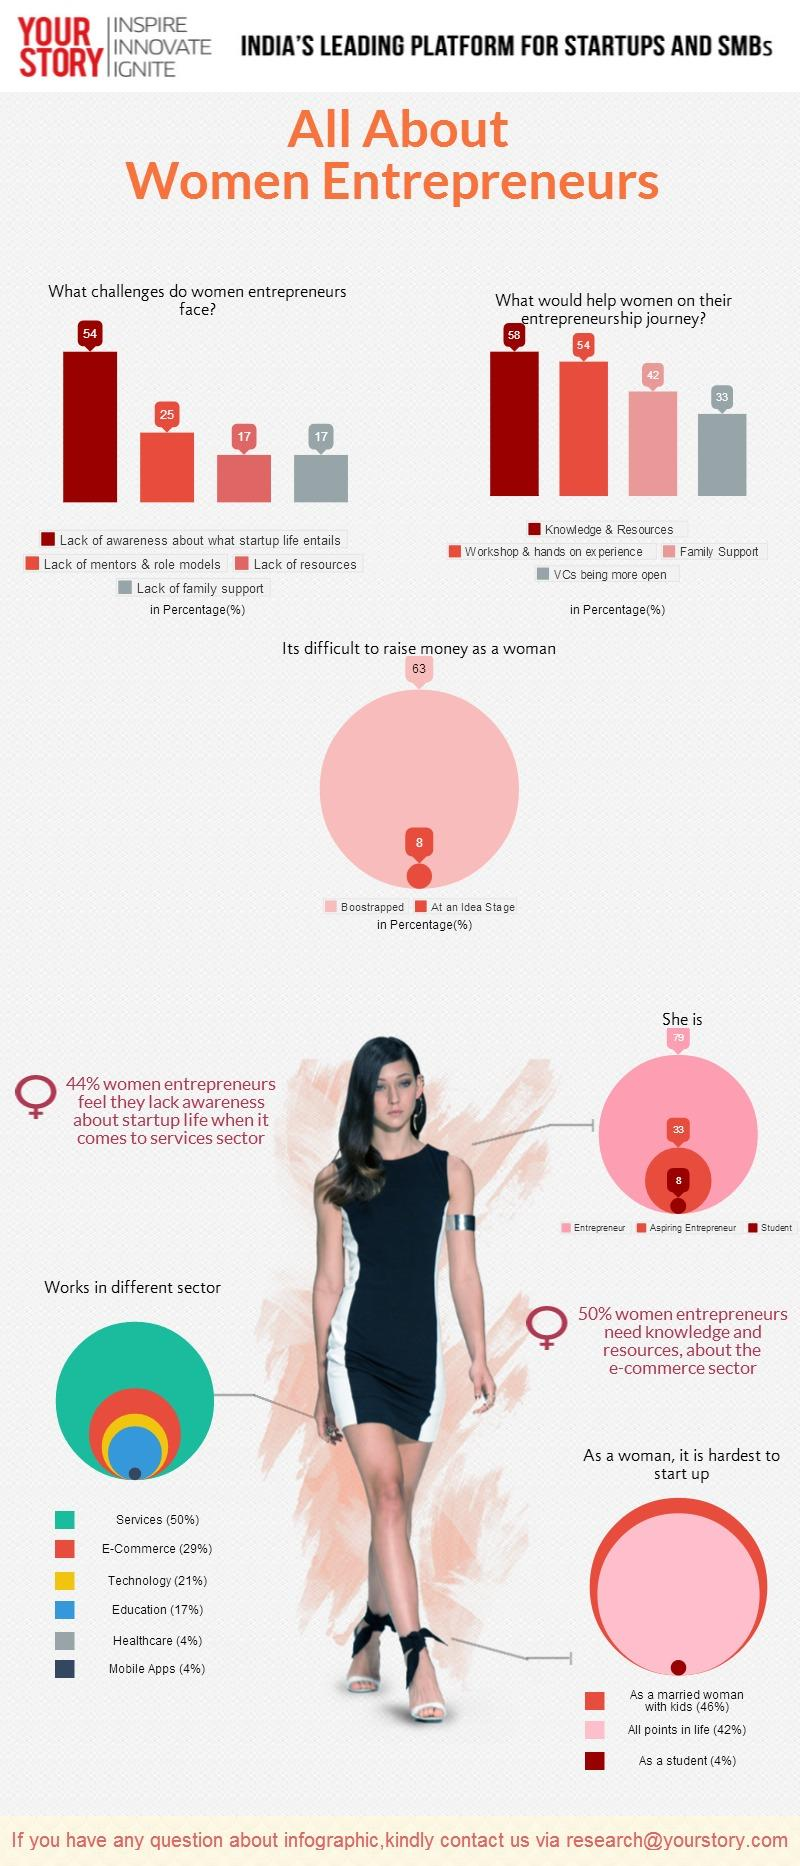Draw attention to some important aspects in this diagram. Lack of mentors and role models is the second-largest difficulty faced by women entrepreneurs. The second largest number of women are working in the e-commerce sector. The color code given to the Education sector is blue. A survey found that 17% of women entrepreneurs face challenges due to limited resources, suggesting that access to resources remains a significant barrier to success for many women in business. The color code assigned to the Technology sector is red, green, yellow, and blue. The Technology sector is assigned the color yellow. 